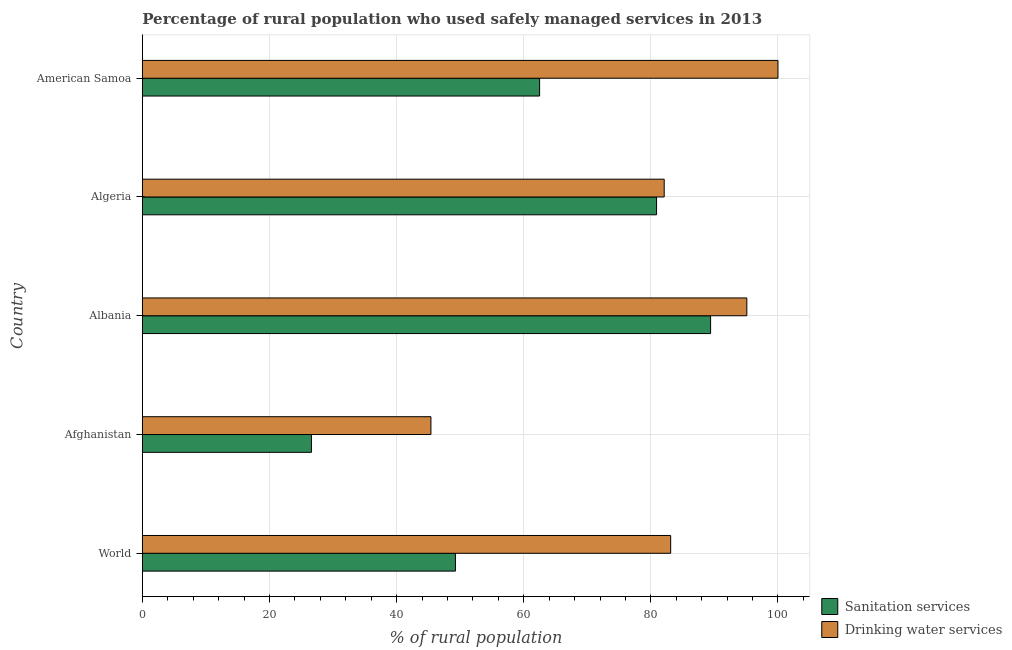Are the number of bars on each tick of the Y-axis equal?
Your answer should be compact. Yes. How many bars are there on the 5th tick from the top?
Your answer should be compact. 2. What is the label of the 3rd group of bars from the top?
Your answer should be compact. Albania. In how many cases, is the number of bars for a given country not equal to the number of legend labels?
Your answer should be compact. 0. What is the percentage of rural population who used sanitation services in American Samoa?
Your answer should be compact. 62.5. Across all countries, what is the maximum percentage of rural population who used sanitation services?
Give a very brief answer. 89.4. Across all countries, what is the minimum percentage of rural population who used drinking water services?
Make the answer very short. 45.4. In which country was the percentage of rural population who used drinking water services maximum?
Offer a terse response. American Samoa. In which country was the percentage of rural population who used drinking water services minimum?
Provide a succinct answer. Afghanistan. What is the total percentage of rural population who used sanitation services in the graph?
Make the answer very short. 308.66. What is the difference between the percentage of rural population who used drinking water services in Algeria and that in World?
Ensure brevity in your answer.  -1.02. What is the difference between the percentage of rural population who used drinking water services in World and the percentage of rural population who used sanitation services in Algeria?
Provide a short and direct response. 2.22. What is the average percentage of rural population who used sanitation services per country?
Provide a succinct answer. 61.73. What is the difference between the percentage of rural population who used drinking water services and percentage of rural population who used sanitation services in American Samoa?
Make the answer very short. 37.5. What is the ratio of the percentage of rural population who used drinking water services in Afghanistan to that in World?
Ensure brevity in your answer.  0.55. Is the percentage of rural population who used sanitation services in Afghanistan less than that in American Samoa?
Make the answer very short. Yes. What is the difference between the highest and the lowest percentage of rural population who used drinking water services?
Provide a short and direct response. 54.6. In how many countries, is the percentage of rural population who used sanitation services greater than the average percentage of rural population who used sanitation services taken over all countries?
Ensure brevity in your answer.  3. What does the 1st bar from the top in Algeria represents?
Make the answer very short. Drinking water services. What does the 2nd bar from the bottom in Algeria represents?
Provide a succinct answer. Drinking water services. How many bars are there?
Make the answer very short. 10. Are all the bars in the graph horizontal?
Give a very brief answer. Yes. What is the difference between two consecutive major ticks on the X-axis?
Ensure brevity in your answer.  20. Does the graph contain grids?
Your answer should be compact. Yes. How are the legend labels stacked?
Give a very brief answer. Vertical. What is the title of the graph?
Ensure brevity in your answer.  Percentage of rural population who used safely managed services in 2013. Does "Time to import" appear as one of the legend labels in the graph?
Ensure brevity in your answer.  No. What is the label or title of the X-axis?
Your response must be concise. % of rural population. What is the label or title of the Y-axis?
Ensure brevity in your answer.  Country. What is the % of rural population of Sanitation services in World?
Your answer should be very brief. 49.26. What is the % of rural population in Drinking water services in World?
Your response must be concise. 83.12. What is the % of rural population in Sanitation services in Afghanistan?
Offer a very short reply. 26.6. What is the % of rural population in Drinking water services in Afghanistan?
Your answer should be very brief. 45.4. What is the % of rural population of Sanitation services in Albania?
Your answer should be compact. 89.4. What is the % of rural population of Drinking water services in Albania?
Your response must be concise. 95.1. What is the % of rural population of Sanitation services in Algeria?
Make the answer very short. 80.9. What is the % of rural population in Drinking water services in Algeria?
Ensure brevity in your answer.  82.1. What is the % of rural population of Sanitation services in American Samoa?
Keep it short and to the point. 62.5. What is the % of rural population of Drinking water services in American Samoa?
Your response must be concise. 100. Across all countries, what is the maximum % of rural population in Sanitation services?
Ensure brevity in your answer.  89.4. Across all countries, what is the maximum % of rural population of Drinking water services?
Keep it short and to the point. 100. Across all countries, what is the minimum % of rural population in Sanitation services?
Provide a short and direct response. 26.6. Across all countries, what is the minimum % of rural population in Drinking water services?
Offer a terse response. 45.4. What is the total % of rural population of Sanitation services in the graph?
Your response must be concise. 308.66. What is the total % of rural population of Drinking water services in the graph?
Provide a succinct answer. 405.72. What is the difference between the % of rural population of Sanitation services in World and that in Afghanistan?
Give a very brief answer. 22.66. What is the difference between the % of rural population in Drinking water services in World and that in Afghanistan?
Give a very brief answer. 37.72. What is the difference between the % of rural population in Sanitation services in World and that in Albania?
Your answer should be very brief. -40.14. What is the difference between the % of rural population of Drinking water services in World and that in Albania?
Offer a terse response. -11.98. What is the difference between the % of rural population in Sanitation services in World and that in Algeria?
Provide a short and direct response. -31.64. What is the difference between the % of rural population of Drinking water services in World and that in Algeria?
Provide a succinct answer. 1.02. What is the difference between the % of rural population in Sanitation services in World and that in American Samoa?
Keep it short and to the point. -13.24. What is the difference between the % of rural population in Drinking water services in World and that in American Samoa?
Offer a terse response. -16.88. What is the difference between the % of rural population in Sanitation services in Afghanistan and that in Albania?
Provide a short and direct response. -62.8. What is the difference between the % of rural population of Drinking water services in Afghanistan and that in Albania?
Make the answer very short. -49.7. What is the difference between the % of rural population of Sanitation services in Afghanistan and that in Algeria?
Offer a very short reply. -54.3. What is the difference between the % of rural population in Drinking water services in Afghanistan and that in Algeria?
Keep it short and to the point. -36.7. What is the difference between the % of rural population in Sanitation services in Afghanistan and that in American Samoa?
Make the answer very short. -35.9. What is the difference between the % of rural population in Drinking water services in Afghanistan and that in American Samoa?
Offer a very short reply. -54.6. What is the difference between the % of rural population in Sanitation services in Albania and that in Algeria?
Your answer should be very brief. 8.5. What is the difference between the % of rural population of Drinking water services in Albania and that in Algeria?
Your answer should be very brief. 13. What is the difference between the % of rural population in Sanitation services in Albania and that in American Samoa?
Your response must be concise. 26.9. What is the difference between the % of rural population in Drinking water services in Albania and that in American Samoa?
Make the answer very short. -4.9. What is the difference between the % of rural population in Drinking water services in Algeria and that in American Samoa?
Offer a terse response. -17.9. What is the difference between the % of rural population in Sanitation services in World and the % of rural population in Drinking water services in Afghanistan?
Provide a succinct answer. 3.86. What is the difference between the % of rural population of Sanitation services in World and the % of rural population of Drinking water services in Albania?
Ensure brevity in your answer.  -45.84. What is the difference between the % of rural population in Sanitation services in World and the % of rural population in Drinking water services in Algeria?
Give a very brief answer. -32.84. What is the difference between the % of rural population in Sanitation services in World and the % of rural population in Drinking water services in American Samoa?
Ensure brevity in your answer.  -50.74. What is the difference between the % of rural population of Sanitation services in Afghanistan and the % of rural population of Drinking water services in Albania?
Give a very brief answer. -68.5. What is the difference between the % of rural population of Sanitation services in Afghanistan and the % of rural population of Drinking water services in Algeria?
Keep it short and to the point. -55.5. What is the difference between the % of rural population of Sanitation services in Afghanistan and the % of rural population of Drinking water services in American Samoa?
Provide a short and direct response. -73.4. What is the difference between the % of rural population in Sanitation services in Albania and the % of rural population in Drinking water services in American Samoa?
Ensure brevity in your answer.  -10.6. What is the difference between the % of rural population of Sanitation services in Algeria and the % of rural population of Drinking water services in American Samoa?
Make the answer very short. -19.1. What is the average % of rural population in Sanitation services per country?
Keep it short and to the point. 61.73. What is the average % of rural population in Drinking water services per country?
Your answer should be compact. 81.14. What is the difference between the % of rural population in Sanitation services and % of rural population in Drinking water services in World?
Your answer should be very brief. -33.86. What is the difference between the % of rural population of Sanitation services and % of rural population of Drinking water services in Afghanistan?
Provide a succinct answer. -18.8. What is the difference between the % of rural population of Sanitation services and % of rural population of Drinking water services in Albania?
Your answer should be compact. -5.7. What is the difference between the % of rural population of Sanitation services and % of rural population of Drinking water services in American Samoa?
Your response must be concise. -37.5. What is the ratio of the % of rural population of Sanitation services in World to that in Afghanistan?
Your answer should be compact. 1.85. What is the ratio of the % of rural population of Drinking water services in World to that in Afghanistan?
Keep it short and to the point. 1.83. What is the ratio of the % of rural population of Sanitation services in World to that in Albania?
Your response must be concise. 0.55. What is the ratio of the % of rural population of Drinking water services in World to that in Albania?
Make the answer very short. 0.87. What is the ratio of the % of rural population in Sanitation services in World to that in Algeria?
Provide a succinct answer. 0.61. What is the ratio of the % of rural population of Drinking water services in World to that in Algeria?
Offer a very short reply. 1.01. What is the ratio of the % of rural population of Sanitation services in World to that in American Samoa?
Your answer should be very brief. 0.79. What is the ratio of the % of rural population in Drinking water services in World to that in American Samoa?
Offer a very short reply. 0.83. What is the ratio of the % of rural population in Sanitation services in Afghanistan to that in Albania?
Give a very brief answer. 0.3. What is the ratio of the % of rural population in Drinking water services in Afghanistan to that in Albania?
Ensure brevity in your answer.  0.48. What is the ratio of the % of rural population of Sanitation services in Afghanistan to that in Algeria?
Your answer should be very brief. 0.33. What is the ratio of the % of rural population in Drinking water services in Afghanistan to that in Algeria?
Offer a terse response. 0.55. What is the ratio of the % of rural population of Sanitation services in Afghanistan to that in American Samoa?
Make the answer very short. 0.43. What is the ratio of the % of rural population in Drinking water services in Afghanistan to that in American Samoa?
Your response must be concise. 0.45. What is the ratio of the % of rural population of Sanitation services in Albania to that in Algeria?
Your answer should be very brief. 1.11. What is the ratio of the % of rural population of Drinking water services in Albania to that in Algeria?
Offer a terse response. 1.16. What is the ratio of the % of rural population in Sanitation services in Albania to that in American Samoa?
Provide a short and direct response. 1.43. What is the ratio of the % of rural population of Drinking water services in Albania to that in American Samoa?
Your answer should be very brief. 0.95. What is the ratio of the % of rural population of Sanitation services in Algeria to that in American Samoa?
Keep it short and to the point. 1.29. What is the ratio of the % of rural population of Drinking water services in Algeria to that in American Samoa?
Provide a short and direct response. 0.82. What is the difference between the highest and the second highest % of rural population in Sanitation services?
Your answer should be compact. 8.5. What is the difference between the highest and the second highest % of rural population of Drinking water services?
Your answer should be compact. 4.9. What is the difference between the highest and the lowest % of rural population in Sanitation services?
Make the answer very short. 62.8. What is the difference between the highest and the lowest % of rural population in Drinking water services?
Make the answer very short. 54.6. 